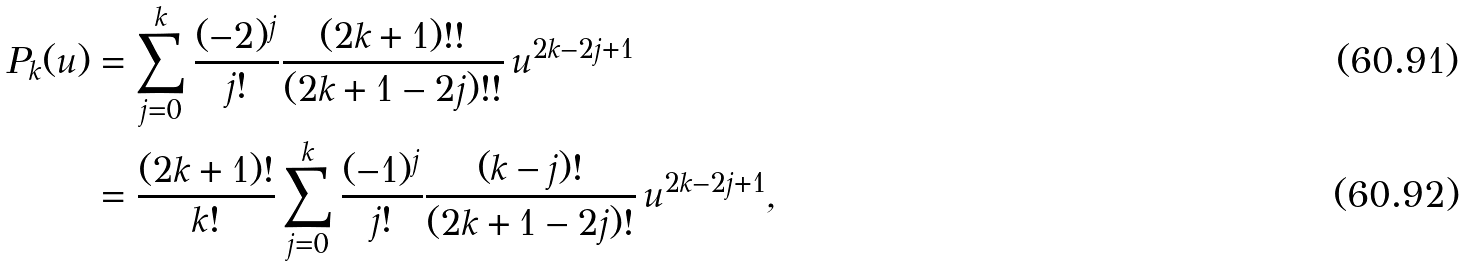Convert formula to latex. <formula><loc_0><loc_0><loc_500><loc_500>P _ { k } ( u ) & = \sum _ { j = 0 } ^ { k } \frac { ( - 2 ) ^ { j } } { j ! } \frac { ( 2 k + 1 ) ! ! } { ( 2 k + 1 - 2 j ) ! ! } \, u ^ { 2 k - 2 j + 1 } \\ & = \frac { ( 2 k + 1 ) ! } { k ! } \sum _ { j = 0 } ^ { k } \frac { ( - 1 ) ^ { j } } { j ! } \frac { ( k - j ) ! } { ( 2 k + 1 - 2 j ) ! } \, u ^ { 2 k - 2 j + 1 } ,</formula> 